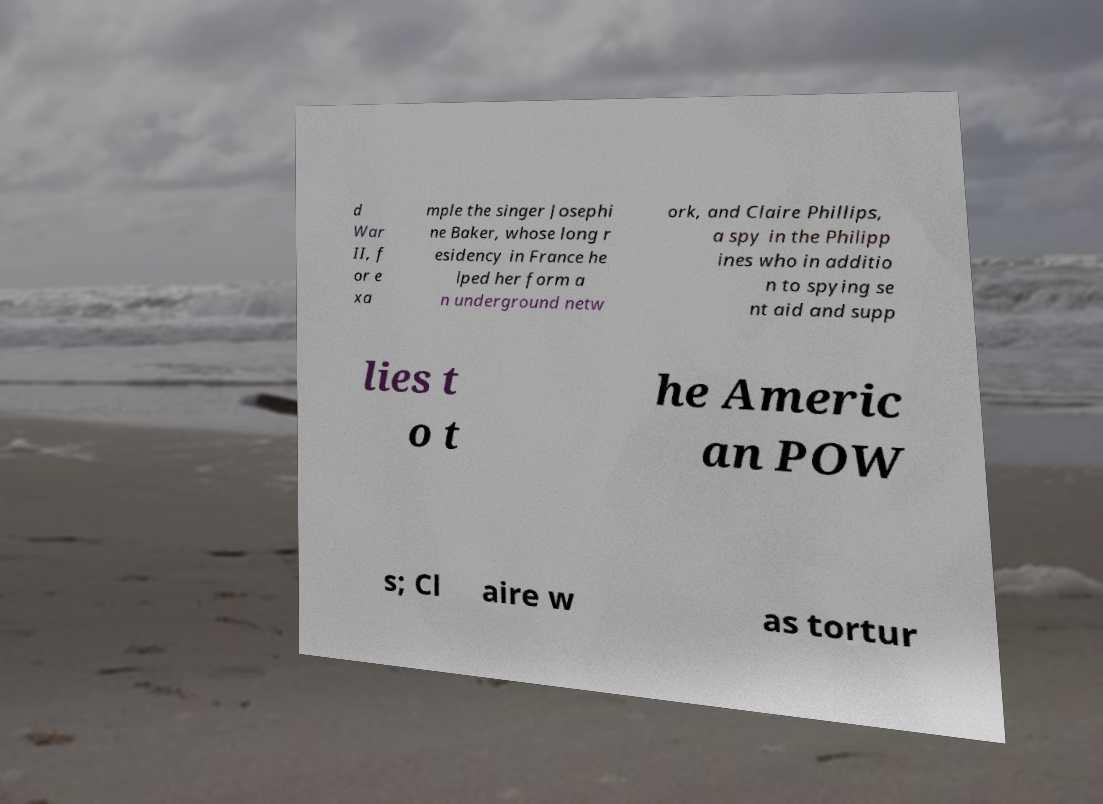What messages or text are displayed in this image? I need them in a readable, typed format. d War II, f or e xa mple the singer Josephi ne Baker, whose long r esidency in France he lped her form a n underground netw ork, and Claire Phillips, a spy in the Philipp ines who in additio n to spying se nt aid and supp lies t o t he Americ an POW s; Cl aire w as tortur 